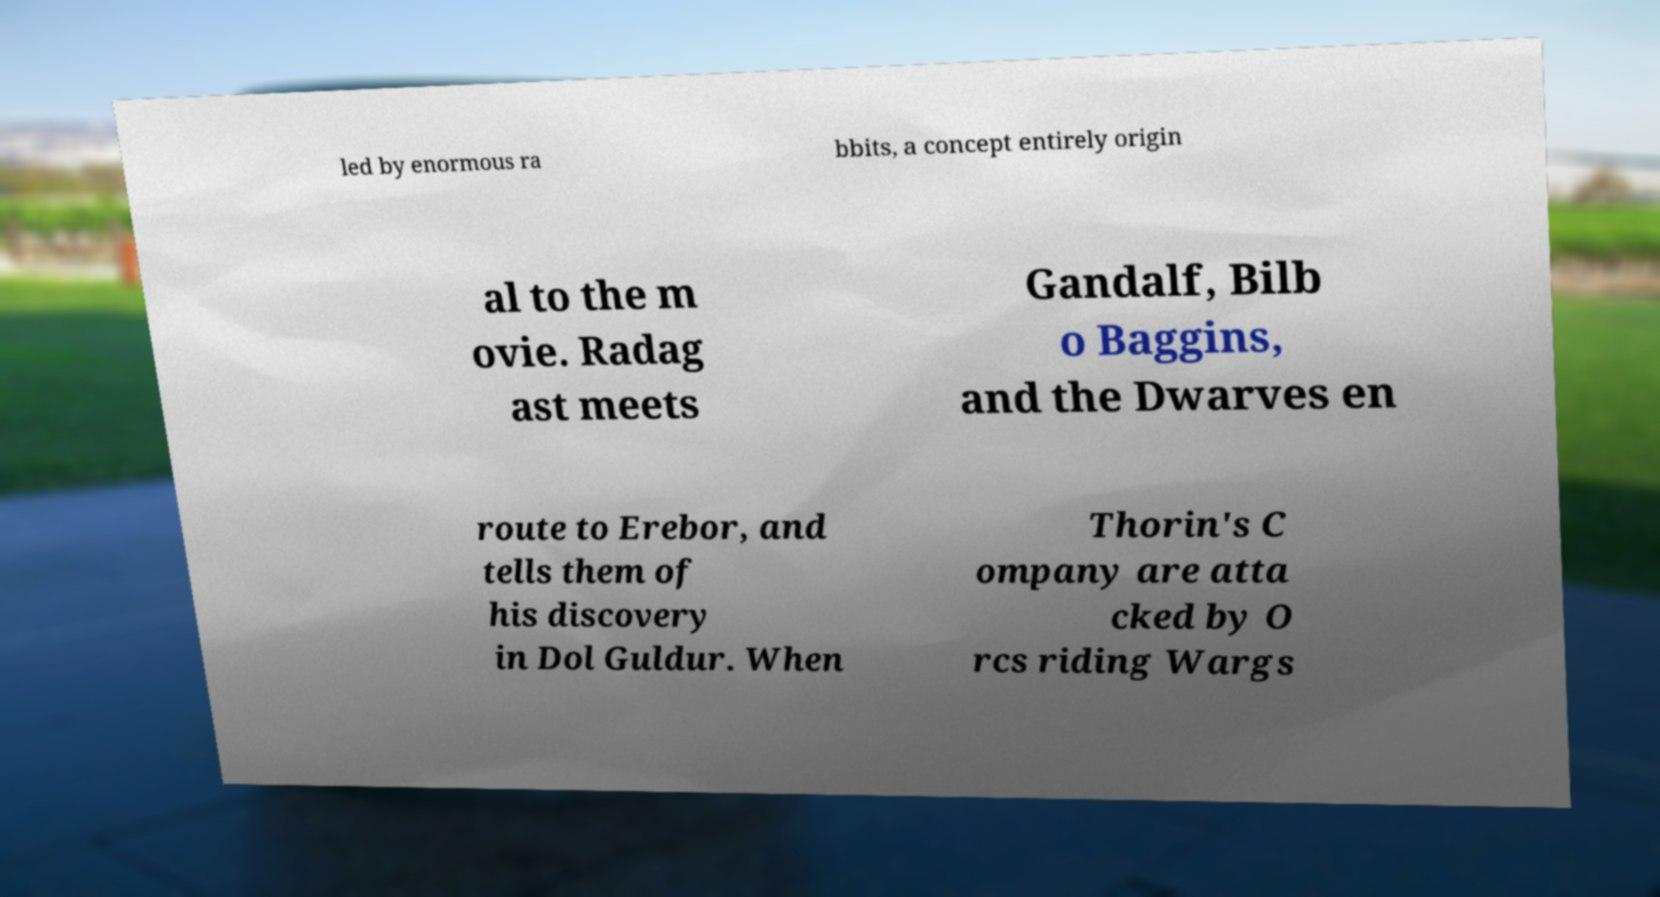I need the written content from this picture converted into text. Can you do that? led by enormous ra bbits, a concept entirely origin al to the m ovie. Radag ast meets Gandalf, Bilb o Baggins, and the Dwarves en route to Erebor, and tells them of his discovery in Dol Guldur. When Thorin's C ompany are atta cked by O rcs riding Wargs 